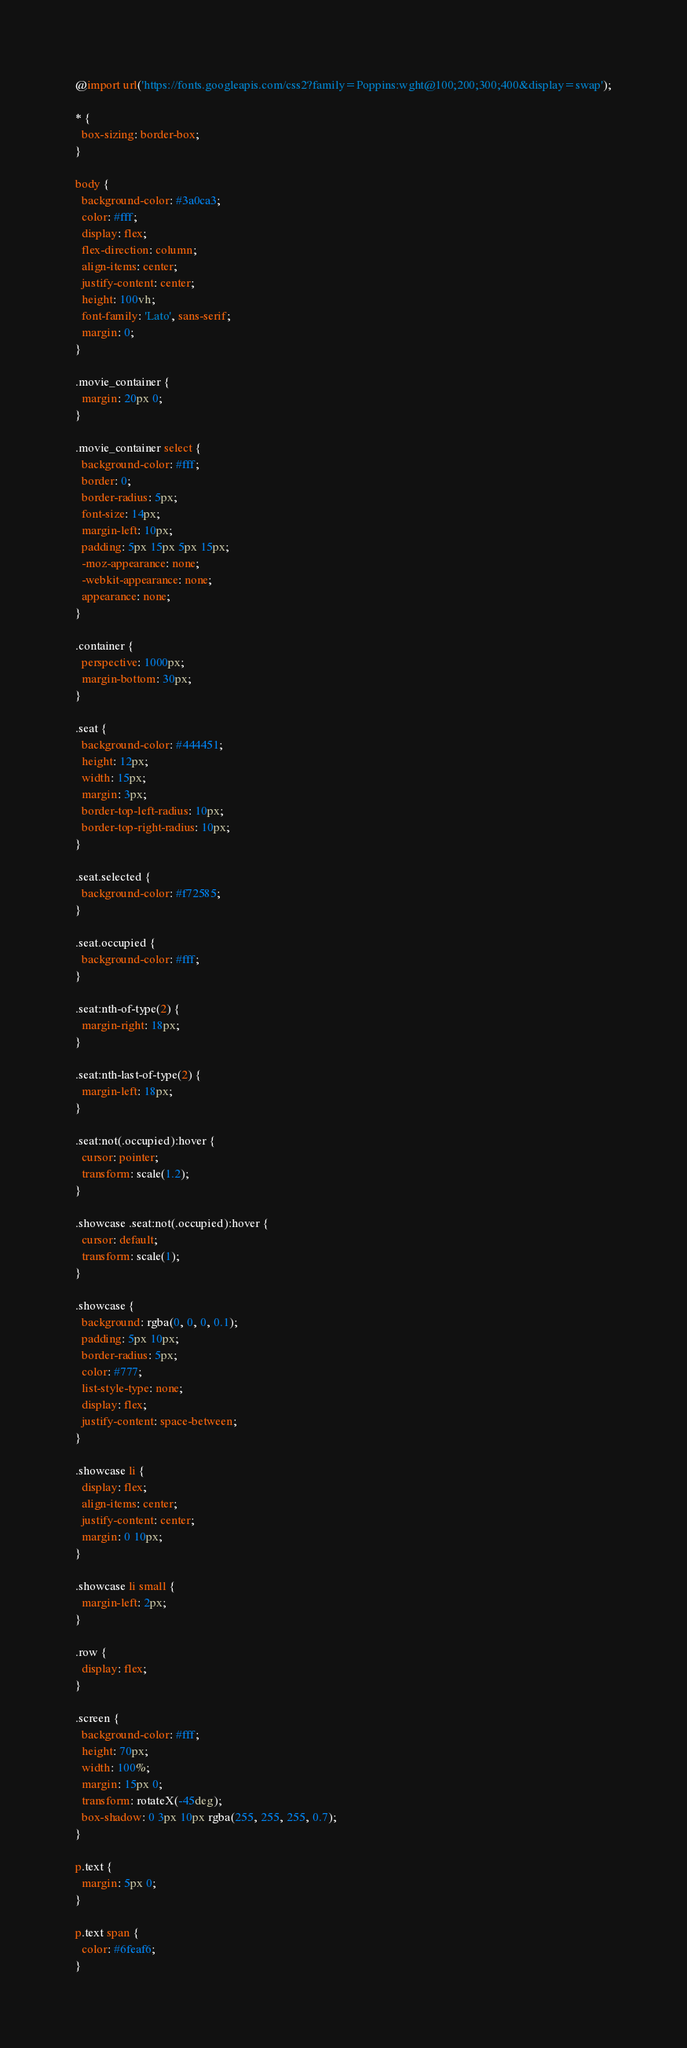<code> <loc_0><loc_0><loc_500><loc_500><_CSS_>@import url('https://fonts.googleapis.com/css2?family=Poppins:wght@100;200;300;400&display=swap');

* {
  box-sizing: border-box;
}

body {
  background-color: #3a0ca3;
  color: #fff;
  display: flex;
  flex-direction: column;
  align-items: center;
  justify-content: center;
  height: 100vh;
  font-family: 'Lato', sans-serif;
  margin: 0;
}

.movie_container {
  margin: 20px 0;
}

.movie_container select {
  background-color: #fff;
  border: 0;
  border-radius: 5px;
  font-size: 14px;
  margin-left: 10px;
  padding: 5px 15px 5px 15px;
  -moz-appearance: none;
  -webkit-appearance: none;
  appearance: none;
}

.container {
  perspective: 1000px;
  margin-bottom: 30px;
}

.seat {
  background-color: #444451;
  height: 12px;
  width: 15px;
  margin: 3px;
  border-top-left-radius: 10px;
  border-top-right-radius: 10px;
}

.seat.selected {
  background-color: #f72585;
}

.seat.occupied {
  background-color: #fff;
}

.seat:nth-of-type(2) {
  margin-right: 18px;
}

.seat:nth-last-of-type(2) {
  margin-left: 18px;
}

.seat:not(.occupied):hover {
  cursor: pointer;
  transform: scale(1.2);
}

.showcase .seat:not(.occupied):hover {
  cursor: default;
  transform: scale(1);
}

.showcase {
  background: rgba(0, 0, 0, 0.1);
  padding: 5px 10px;
  border-radius: 5px;
  color: #777;
  list-style-type: none;
  display: flex;
  justify-content: space-between;
}

.showcase li {
  display: flex;
  align-items: center;
  justify-content: center;
  margin: 0 10px;
}

.showcase li small {
  margin-left: 2px;
}

.row {
  display: flex;
}

.screen {
  background-color: #fff;
  height: 70px;
  width: 100%;
  margin: 15px 0;
  transform: rotateX(-45deg);
  box-shadow: 0 3px 10px rgba(255, 255, 255, 0.7);
}

p.text {
  margin: 5px 0;
}

p.text span {
  color: #6feaf6;
}
</code> 